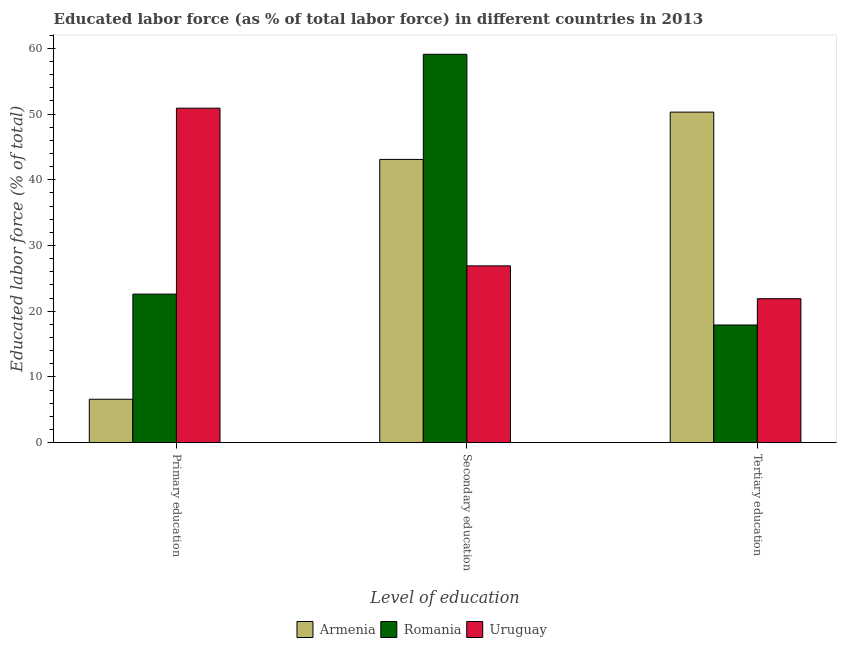Are the number of bars per tick equal to the number of legend labels?
Provide a succinct answer. Yes. How many bars are there on the 3rd tick from the right?
Offer a terse response. 3. What is the percentage of labor force who received tertiary education in Uruguay?
Keep it short and to the point. 21.9. Across all countries, what is the maximum percentage of labor force who received tertiary education?
Keep it short and to the point. 50.3. Across all countries, what is the minimum percentage of labor force who received tertiary education?
Your answer should be compact. 17.9. In which country was the percentage of labor force who received primary education maximum?
Make the answer very short. Uruguay. In which country was the percentage of labor force who received tertiary education minimum?
Offer a terse response. Romania. What is the total percentage of labor force who received secondary education in the graph?
Ensure brevity in your answer.  129.1. What is the difference between the percentage of labor force who received tertiary education in Armenia and that in Uruguay?
Provide a succinct answer. 28.4. What is the difference between the percentage of labor force who received tertiary education in Armenia and the percentage of labor force who received secondary education in Romania?
Provide a succinct answer. -8.8. What is the average percentage of labor force who received secondary education per country?
Make the answer very short. 43.03. What is the difference between the percentage of labor force who received secondary education and percentage of labor force who received primary education in Uruguay?
Keep it short and to the point. -24. In how many countries, is the percentage of labor force who received primary education greater than 14 %?
Offer a very short reply. 2. What is the ratio of the percentage of labor force who received secondary education in Uruguay to that in Armenia?
Offer a terse response. 0.62. Is the difference between the percentage of labor force who received tertiary education in Uruguay and Romania greater than the difference between the percentage of labor force who received primary education in Uruguay and Romania?
Offer a terse response. No. What is the difference between the highest and the lowest percentage of labor force who received tertiary education?
Offer a very short reply. 32.4. What does the 2nd bar from the left in Tertiary education represents?
Your answer should be compact. Romania. What does the 1st bar from the right in Primary education represents?
Your response must be concise. Uruguay. Is it the case that in every country, the sum of the percentage of labor force who received primary education and percentage of labor force who received secondary education is greater than the percentage of labor force who received tertiary education?
Make the answer very short. No. How many bars are there?
Keep it short and to the point. 9. Are all the bars in the graph horizontal?
Give a very brief answer. No. How many countries are there in the graph?
Offer a very short reply. 3. What is the difference between two consecutive major ticks on the Y-axis?
Your answer should be very brief. 10. Does the graph contain any zero values?
Ensure brevity in your answer.  No. Where does the legend appear in the graph?
Your response must be concise. Bottom center. How many legend labels are there?
Give a very brief answer. 3. How are the legend labels stacked?
Offer a very short reply. Horizontal. What is the title of the graph?
Provide a short and direct response. Educated labor force (as % of total labor force) in different countries in 2013. Does "Albania" appear as one of the legend labels in the graph?
Offer a terse response. No. What is the label or title of the X-axis?
Provide a succinct answer. Level of education. What is the label or title of the Y-axis?
Ensure brevity in your answer.  Educated labor force (% of total). What is the Educated labor force (% of total) in Armenia in Primary education?
Offer a terse response. 6.6. What is the Educated labor force (% of total) in Romania in Primary education?
Offer a very short reply. 22.6. What is the Educated labor force (% of total) in Uruguay in Primary education?
Ensure brevity in your answer.  50.9. What is the Educated labor force (% of total) of Armenia in Secondary education?
Keep it short and to the point. 43.1. What is the Educated labor force (% of total) in Romania in Secondary education?
Your answer should be very brief. 59.1. What is the Educated labor force (% of total) in Uruguay in Secondary education?
Make the answer very short. 26.9. What is the Educated labor force (% of total) of Armenia in Tertiary education?
Make the answer very short. 50.3. What is the Educated labor force (% of total) of Romania in Tertiary education?
Make the answer very short. 17.9. What is the Educated labor force (% of total) of Uruguay in Tertiary education?
Your answer should be compact. 21.9. Across all Level of education, what is the maximum Educated labor force (% of total) in Armenia?
Keep it short and to the point. 50.3. Across all Level of education, what is the maximum Educated labor force (% of total) in Romania?
Keep it short and to the point. 59.1. Across all Level of education, what is the maximum Educated labor force (% of total) in Uruguay?
Keep it short and to the point. 50.9. Across all Level of education, what is the minimum Educated labor force (% of total) in Armenia?
Offer a terse response. 6.6. Across all Level of education, what is the minimum Educated labor force (% of total) of Romania?
Your answer should be compact. 17.9. Across all Level of education, what is the minimum Educated labor force (% of total) in Uruguay?
Provide a short and direct response. 21.9. What is the total Educated labor force (% of total) of Romania in the graph?
Keep it short and to the point. 99.6. What is the total Educated labor force (% of total) of Uruguay in the graph?
Keep it short and to the point. 99.7. What is the difference between the Educated labor force (% of total) of Armenia in Primary education and that in Secondary education?
Ensure brevity in your answer.  -36.5. What is the difference between the Educated labor force (% of total) in Romania in Primary education and that in Secondary education?
Offer a terse response. -36.5. What is the difference between the Educated labor force (% of total) in Armenia in Primary education and that in Tertiary education?
Make the answer very short. -43.7. What is the difference between the Educated labor force (% of total) of Uruguay in Primary education and that in Tertiary education?
Offer a very short reply. 29. What is the difference between the Educated labor force (% of total) of Armenia in Secondary education and that in Tertiary education?
Make the answer very short. -7.2. What is the difference between the Educated labor force (% of total) of Romania in Secondary education and that in Tertiary education?
Offer a terse response. 41.2. What is the difference between the Educated labor force (% of total) of Uruguay in Secondary education and that in Tertiary education?
Offer a very short reply. 5. What is the difference between the Educated labor force (% of total) in Armenia in Primary education and the Educated labor force (% of total) in Romania in Secondary education?
Ensure brevity in your answer.  -52.5. What is the difference between the Educated labor force (% of total) of Armenia in Primary education and the Educated labor force (% of total) of Uruguay in Secondary education?
Your answer should be very brief. -20.3. What is the difference between the Educated labor force (% of total) in Armenia in Primary education and the Educated labor force (% of total) in Uruguay in Tertiary education?
Keep it short and to the point. -15.3. What is the difference between the Educated labor force (% of total) of Armenia in Secondary education and the Educated labor force (% of total) of Romania in Tertiary education?
Your answer should be very brief. 25.2. What is the difference between the Educated labor force (% of total) in Armenia in Secondary education and the Educated labor force (% of total) in Uruguay in Tertiary education?
Your response must be concise. 21.2. What is the difference between the Educated labor force (% of total) in Romania in Secondary education and the Educated labor force (% of total) in Uruguay in Tertiary education?
Provide a succinct answer. 37.2. What is the average Educated labor force (% of total) in Armenia per Level of education?
Give a very brief answer. 33.33. What is the average Educated labor force (% of total) in Romania per Level of education?
Make the answer very short. 33.2. What is the average Educated labor force (% of total) in Uruguay per Level of education?
Offer a very short reply. 33.23. What is the difference between the Educated labor force (% of total) in Armenia and Educated labor force (% of total) in Romania in Primary education?
Keep it short and to the point. -16. What is the difference between the Educated labor force (% of total) of Armenia and Educated labor force (% of total) of Uruguay in Primary education?
Provide a succinct answer. -44.3. What is the difference between the Educated labor force (% of total) in Romania and Educated labor force (% of total) in Uruguay in Primary education?
Provide a succinct answer. -28.3. What is the difference between the Educated labor force (% of total) of Armenia and Educated labor force (% of total) of Uruguay in Secondary education?
Your response must be concise. 16.2. What is the difference between the Educated labor force (% of total) of Romania and Educated labor force (% of total) of Uruguay in Secondary education?
Make the answer very short. 32.2. What is the difference between the Educated labor force (% of total) in Armenia and Educated labor force (% of total) in Romania in Tertiary education?
Keep it short and to the point. 32.4. What is the difference between the Educated labor force (% of total) of Armenia and Educated labor force (% of total) of Uruguay in Tertiary education?
Make the answer very short. 28.4. What is the ratio of the Educated labor force (% of total) of Armenia in Primary education to that in Secondary education?
Your answer should be compact. 0.15. What is the ratio of the Educated labor force (% of total) in Romania in Primary education to that in Secondary education?
Provide a succinct answer. 0.38. What is the ratio of the Educated labor force (% of total) in Uruguay in Primary education to that in Secondary education?
Give a very brief answer. 1.89. What is the ratio of the Educated labor force (% of total) in Armenia in Primary education to that in Tertiary education?
Offer a very short reply. 0.13. What is the ratio of the Educated labor force (% of total) of Romania in Primary education to that in Tertiary education?
Offer a very short reply. 1.26. What is the ratio of the Educated labor force (% of total) in Uruguay in Primary education to that in Tertiary education?
Your response must be concise. 2.32. What is the ratio of the Educated labor force (% of total) in Armenia in Secondary education to that in Tertiary education?
Ensure brevity in your answer.  0.86. What is the ratio of the Educated labor force (% of total) of Romania in Secondary education to that in Tertiary education?
Provide a succinct answer. 3.3. What is the ratio of the Educated labor force (% of total) in Uruguay in Secondary education to that in Tertiary education?
Ensure brevity in your answer.  1.23. What is the difference between the highest and the second highest Educated labor force (% of total) of Romania?
Your answer should be very brief. 36.5. What is the difference between the highest and the lowest Educated labor force (% of total) of Armenia?
Your answer should be compact. 43.7. What is the difference between the highest and the lowest Educated labor force (% of total) of Romania?
Offer a very short reply. 41.2. 